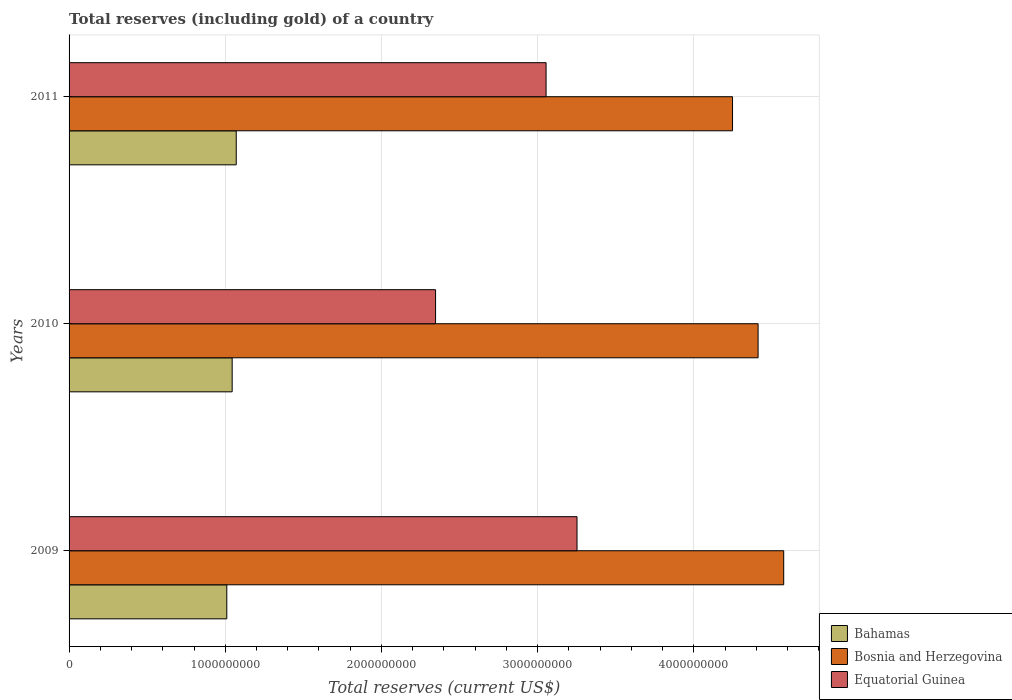How many groups of bars are there?
Provide a short and direct response. 3. Are the number of bars per tick equal to the number of legend labels?
Offer a terse response. Yes. Are the number of bars on each tick of the Y-axis equal?
Provide a succinct answer. Yes. How many bars are there on the 3rd tick from the bottom?
Offer a very short reply. 3. What is the label of the 3rd group of bars from the top?
Your answer should be compact. 2009. What is the total reserves (including gold) in Equatorial Guinea in 2011?
Make the answer very short. 3.05e+09. Across all years, what is the maximum total reserves (including gold) in Equatorial Guinea?
Your answer should be very brief. 3.25e+09. Across all years, what is the minimum total reserves (including gold) in Bosnia and Herzegovina?
Make the answer very short. 4.25e+09. What is the total total reserves (including gold) in Equatorial Guinea in the graph?
Your response must be concise. 8.65e+09. What is the difference between the total reserves (including gold) in Bahamas in 2010 and that in 2011?
Offer a very short reply. -2.61e+07. What is the difference between the total reserves (including gold) in Bosnia and Herzegovina in 2009 and the total reserves (including gold) in Bahamas in 2011?
Keep it short and to the point. 3.50e+09. What is the average total reserves (including gold) in Bahamas per year?
Offer a very short reply. 1.04e+09. In the year 2009, what is the difference between the total reserves (including gold) in Equatorial Guinea and total reserves (including gold) in Bosnia and Herzegovina?
Your response must be concise. -1.32e+09. In how many years, is the total reserves (including gold) in Bahamas greater than 3600000000 US$?
Your answer should be very brief. 0. What is the ratio of the total reserves (including gold) in Bahamas in 2009 to that in 2011?
Give a very brief answer. 0.94. Is the total reserves (including gold) in Bahamas in 2009 less than that in 2010?
Offer a terse response. Yes. Is the difference between the total reserves (including gold) in Equatorial Guinea in 2010 and 2011 greater than the difference between the total reserves (including gold) in Bosnia and Herzegovina in 2010 and 2011?
Offer a very short reply. No. What is the difference between the highest and the second highest total reserves (including gold) in Bosnia and Herzegovina?
Your answer should be very brief. 1.64e+08. What is the difference between the highest and the lowest total reserves (including gold) in Bahamas?
Make the answer very short. 6.04e+07. Is the sum of the total reserves (including gold) in Equatorial Guinea in 2009 and 2011 greater than the maximum total reserves (including gold) in Bahamas across all years?
Ensure brevity in your answer.  Yes. What does the 3rd bar from the top in 2010 represents?
Offer a terse response. Bahamas. What does the 3rd bar from the bottom in 2009 represents?
Your response must be concise. Equatorial Guinea. How many bars are there?
Offer a terse response. 9. What is the difference between two consecutive major ticks on the X-axis?
Make the answer very short. 1.00e+09. Does the graph contain any zero values?
Give a very brief answer. No. Does the graph contain grids?
Offer a terse response. Yes. What is the title of the graph?
Offer a terse response. Total reserves (including gold) of a country. What is the label or title of the X-axis?
Offer a terse response. Total reserves (current US$). What is the Total reserves (current US$) of Bahamas in 2009?
Make the answer very short. 1.01e+09. What is the Total reserves (current US$) of Bosnia and Herzegovina in 2009?
Your response must be concise. 4.58e+09. What is the Total reserves (current US$) in Equatorial Guinea in 2009?
Give a very brief answer. 3.25e+09. What is the Total reserves (current US$) of Bahamas in 2010?
Provide a short and direct response. 1.04e+09. What is the Total reserves (current US$) in Bosnia and Herzegovina in 2010?
Make the answer very short. 4.41e+09. What is the Total reserves (current US$) in Equatorial Guinea in 2010?
Your response must be concise. 2.35e+09. What is the Total reserves (current US$) of Bahamas in 2011?
Your response must be concise. 1.07e+09. What is the Total reserves (current US$) of Bosnia and Herzegovina in 2011?
Ensure brevity in your answer.  4.25e+09. What is the Total reserves (current US$) of Equatorial Guinea in 2011?
Provide a short and direct response. 3.05e+09. Across all years, what is the maximum Total reserves (current US$) in Bahamas?
Your answer should be compact. 1.07e+09. Across all years, what is the maximum Total reserves (current US$) of Bosnia and Herzegovina?
Provide a short and direct response. 4.58e+09. Across all years, what is the maximum Total reserves (current US$) in Equatorial Guinea?
Make the answer very short. 3.25e+09. Across all years, what is the minimum Total reserves (current US$) in Bahamas?
Ensure brevity in your answer.  1.01e+09. Across all years, what is the minimum Total reserves (current US$) in Bosnia and Herzegovina?
Make the answer very short. 4.25e+09. Across all years, what is the minimum Total reserves (current US$) in Equatorial Guinea?
Provide a succinct answer. 2.35e+09. What is the total Total reserves (current US$) of Bahamas in the graph?
Keep it short and to the point. 3.12e+09. What is the total Total reserves (current US$) in Bosnia and Herzegovina in the graph?
Give a very brief answer. 1.32e+1. What is the total Total reserves (current US$) of Equatorial Guinea in the graph?
Provide a short and direct response. 8.65e+09. What is the difference between the Total reserves (current US$) of Bahamas in 2009 and that in 2010?
Keep it short and to the point. -3.43e+07. What is the difference between the Total reserves (current US$) of Bosnia and Herzegovina in 2009 and that in 2010?
Your answer should be compact. 1.64e+08. What is the difference between the Total reserves (current US$) of Equatorial Guinea in 2009 and that in 2010?
Ensure brevity in your answer.  9.06e+08. What is the difference between the Total reserves (current US$) of Bahamas in 2009 and that in 2011?
Provide a succinct answer. -6.04e+07. What is the difference between the Total reserves (current US$) in Bosnia and Herzegovina in 2009 and that in 2011?
Offer a very short reply. 3.28e+08. What is the difference between the Total reserves (current US$) in Equatorial Guinea in 2009 and that in 2011?
Provide a succinct answer. 1.98e+08. What is the difference between the Total reserves (current US$) in Bahamas in 2010 and that in 2011?
Make the answer very short. -2.61e+07. What is the difference between the Total reserves (current US$) of Bosnia and Herzegovina in 2010 and that in 2011?
Offer a very short reply. 1.64e+08. What is the difference between the Total reserves (current US$) of Equatorial Guinea in 2010 and that in 2011?
Offer a very short reply. -7.07e+08. What is the difference between the Total reserves (current US$) in Bahamas in 2009 and the Total reserves (current US$) in Bosnia and Herzegovina in 2010?
Your answer should be very brief. -3.40e+09. What is the difference between the Total reserves (current US$) in Bahamas in 2009 and the Total reserves (current US$) in Equatorial Guinea in 2010?
Give a very brief answer. -1.34e+09. What is the difference between the Total reserves (current US$) of Bosnia and Herzegovina in 2009 and the Total reserves (current US$) of Equatorial Guinea in 2010?
Offer a very short reply. 2.23e+09. What is the difference between the Total reserves (current US$) of Bahamas in 2009 and the Total reserves (current US$) of Bosnia and Herzegovina in 2011?
Offer a very short reply. -3.24e+09. What is the difference between the Total reserves (current US$) of Bahamas in 2009 and the Total reserves (current US$) of Equatorial Guinea in 2011?
Keep it short and to the point. -2.04e+09. What is the difference between the Total reserves (current US$) in Bosnia and Herzegovina in 2009 and the Total reserves (current US$) in Equatorial Guinea in 2011?
Your answer should be very brief. 1.52e+09. What is the difference between the Total reserves (current US$) of Bahamas in 2010 and the Total reserves (current US$) of Bosnia and Herzegovina in 2011?
Provide a succinct answer. -3.20e+09. What is the difference between the Total reserves (current US$) in Bahamas in 2010 and the Total reserves (current US$) in Equatorial Guinea in 2011?
Offer a terse response. -2.01e+09. What is the difference between the Total reserves (current US$) of Bosnia and Herzegovina in 2010 and the Total reserves (current US$) of Equatorial Guinea in 2011?
Offer a very short reply. 1.36e+09. What is the average Total reserves (current US$) in Bahamas per year?
Ensure brevity in your answer.  1.04e+09. What is the average Total reserves (current US$) in Bosnia and Herzegovina per year?
Your answer should be compact. 4.41e+09. What is the average Total reserves (current US$) in Equatorial Guinea per year?
Give a very brief answer. 2.88e+09. In the year 2009, what is the difference between the Total reserves (current US$) in Bahamas and Total reserves (current US$) in Bosnia and Herzegovina?
Keep it short and to the point. -3.57e+09. In the year 2009, what is the difference between the Total reserves (current US$) of Bahamas and Total reserves (current US$) of Equatorial Guinea?
Ensure brevity in your answer.  -2.24e+09. In the year 2009, what is the difference between the Total reserves (current US$) in Bosnia and Herzegovina and Total reserves (current US$) in Equatorial Guinea?
Make the answer very short. 1.32e+09. In the year 2010, what is the difference between the Total reserves (current US$) of Bahamas and Total reserves (current US$) of Bosnia and Herzegovina?
Provide a succinct answer. -3.37e+09. In the year 2010, what is the difference between the Total reserves (current US$) of Bahamas and Total reserves (current US$) of Equatorial Guinea?
Your answer should be compact. -1.30e+09. In the year 2010, what is the difference between the Total reserves (current US$) of Bosnia and Herzegovina and Total reserves (current US$) of Equatorial Guinea?
Your answer should be compact. 2.06e+09. In the year 2011, what is the difference between the Total reserves (current US$) of Bahamas and Total reserves (current US$) of Bosnia and Herzegovina?
Your answer should be very brief. -3.18e+09. In the year 2011, what is the difference between the Total reserves (current US$) of Bahamas and Total reserves (current US$) of Equatorial Guinea?
Your response must be concise. -1.98e+09. In the year 2011, what is the difference between the Total reserves (current US$) in Bosnia and Herzegovina and Total reserves (current US$) in Equatorial Guinea?
Offer a terse response. 1.19e+09. What is the ratio of the Total reserves (current US$) in Bahamas in 2009 to that in 2010?
Provide a succinct answer. 0.97. What is the ratio of the Total reserves (current US$) of Bosnia and Herzegovina in 2009 to that in 2010?
Your answer should be compact. 1.04. What is the ratio of the Total reserves (current US$) of Equatorial Guinea in 2009 to that in 2010?
Make the answer very short. 1.39. What is the ratio of the Total reserves (current US$) of Bahamas in 2009 to that in 2011?
Offer a terse response. 0.94. What is the ratio of the Total reserves (current US$) of Bosnia and Herzegovina in 2009 to that in 2011?
Keep it short and to the point. 1.08. What is the ratio of the Total reserves (current US$) in Equatorial Guinea in 2009 to that in 2011?
Your answer should be compact. 1.06. What is the ratio of the Total reserves (current US$) of Bahamas in 2010 to that in 2011?
Ensure brevity in your answer.  0.98. What is the ratio of the Total reserves (current US$) in Equatorial Guinea in 2010 to that in 2011?
Make the answer very short. 0.77. What is the difference between the highest and the second highest Total reserves (current US$) in Bahamas?
Your answer should be very brief. 2.61e+07. What is the difference between the highest and the second highest Total reserves (current US$) in Bosnia and Herzegovina?
Your answer should be compact. 1.64e+08. What is the difference between the highest and the second highest Total reserves (current US$) of Equatorial Guinea?
Ensure brevity in your answer.  1.98e+08. What is the difference between the highest and the lowest Total reserves (current US$) of Bahamas?
Offer a terse response. 6.04e+07. What is the difference between the highest and the lowest Total reserves (current US$) in Bosnia and Herzegovina?
Your answer should be compact. 3.28e+08. What is the difference between the highest and the lowest Total reserves (current US$) of Equatorial Guinea?
Make the answer very short. 9.06e+08. 